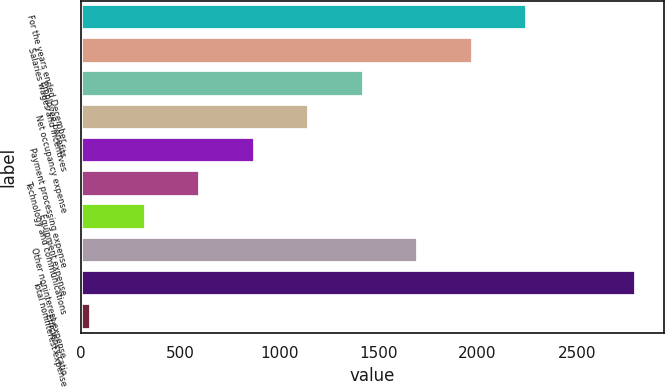Convert chart to OTSL. <chart><loc_0><loc_0><loc_500><loc_500><bar_chart><fcel>For the years ended December<fcel>Salaries wages and incentives<fcel>Employee benefits<fcel>Net occupancy expense<fcel>Payment processing expense<fcel>Technology and communications<fcel>Equipment expense<fcel>Other noninterest expense<fcel>Total noninterest expense<fcel>Efficiency ratio<nl><fcel>2251.22<fcel>1976.33<fcel>1426.55<fcel>1151.66<fcel>876.77<fcel>601.88<fcel>326.99<fcel>1701.44<fcel>2801<fcel>52.1<nl></chart> 